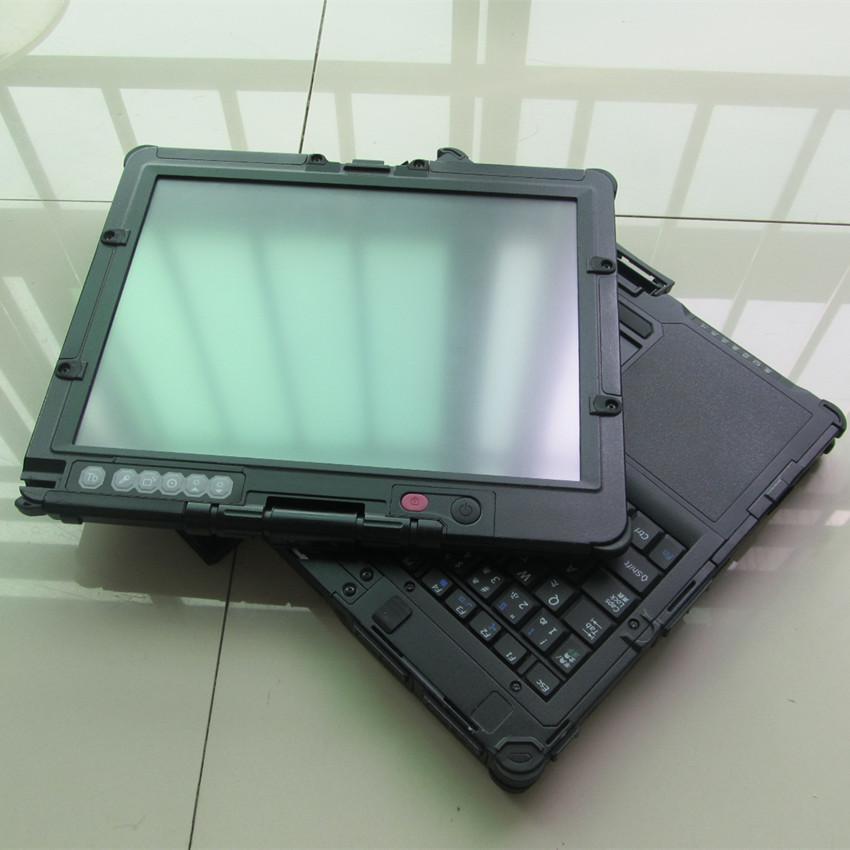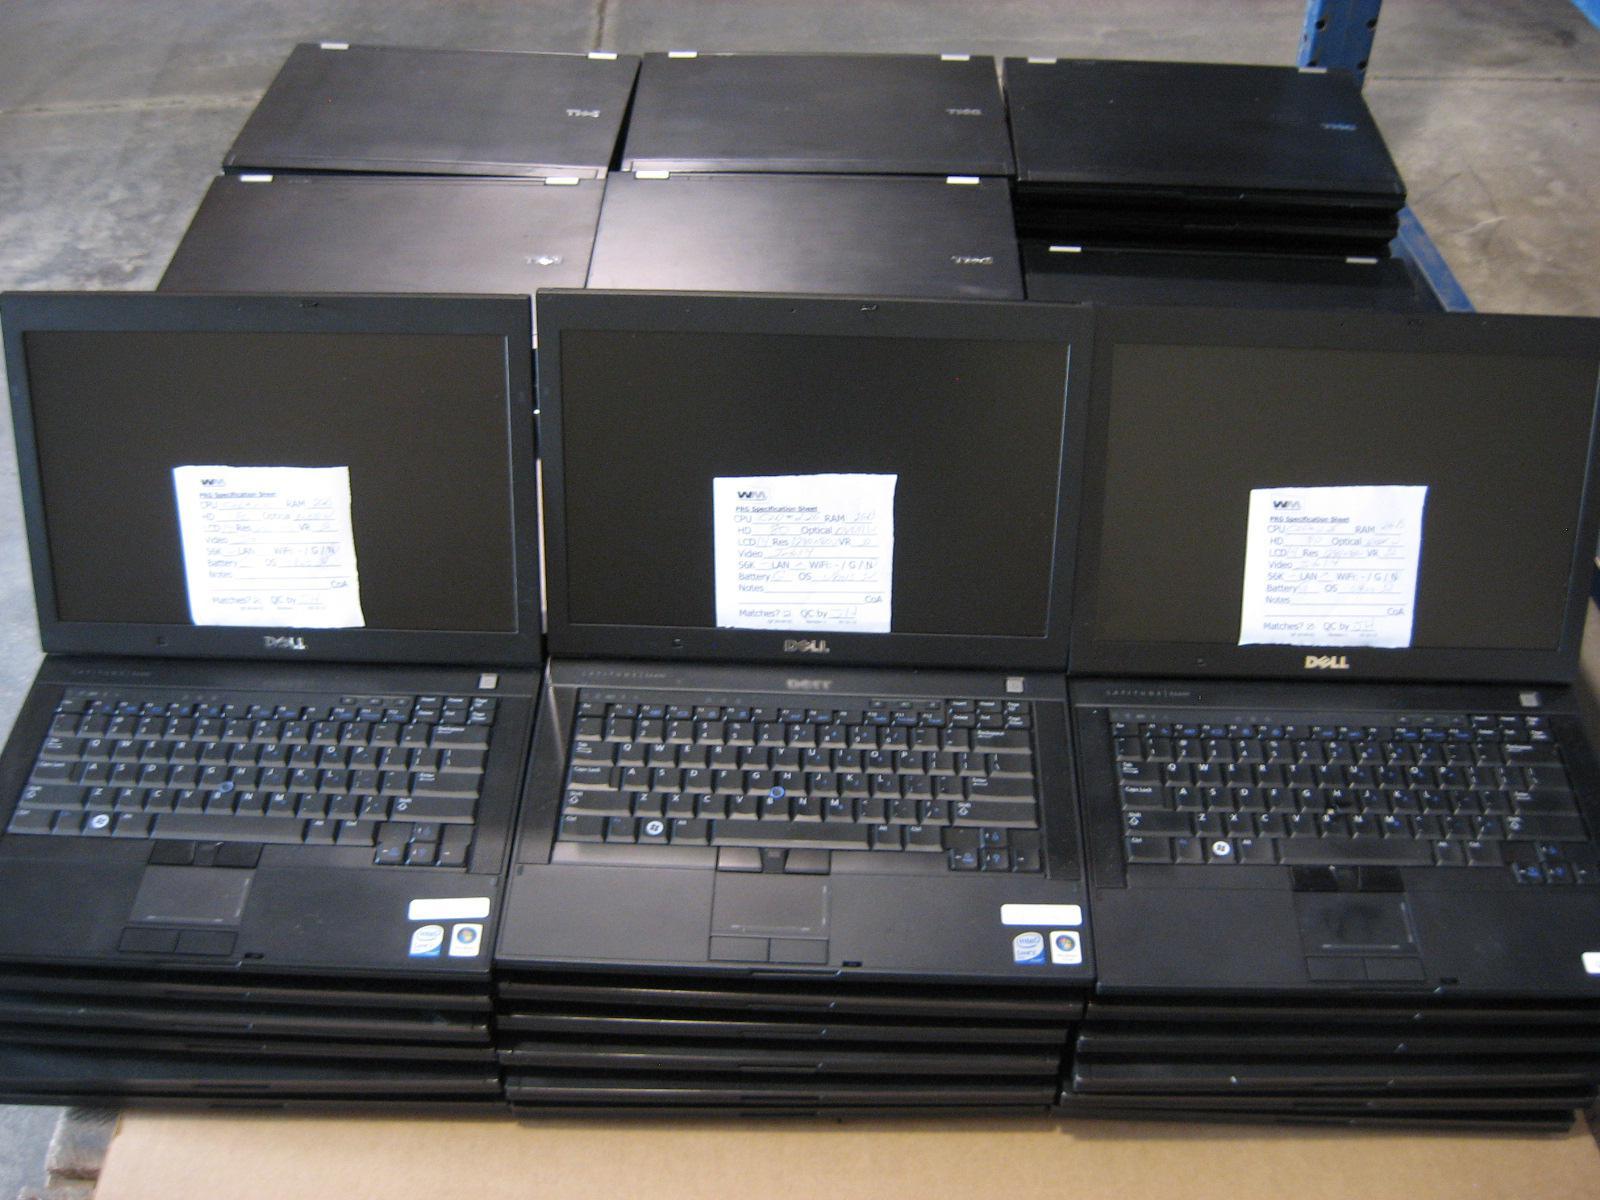The first image is the image on the left, the second image is the image on the right. Given the left and right images, does the statement "In one image, laptop computers are lined in rows three across, with at least the first row fully open." hold true? Answer yes or no. Yes. The first image is the image on the left, the second image is the image on the right. Considering the images on both sides, is "An image shows rows of lap stocks arranged three across." valid? Answer yes or no. Yes. 